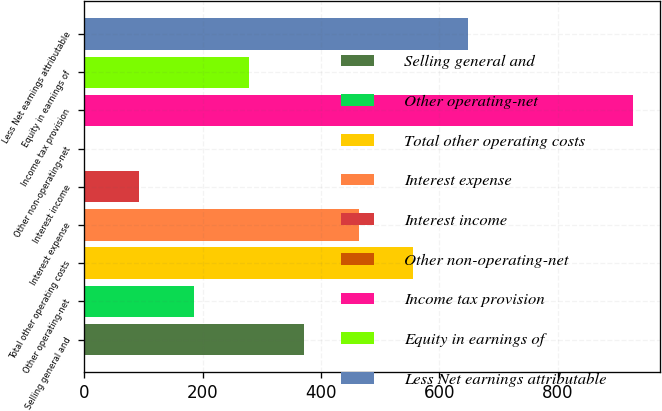Convert chart. <chart><loc_0><loc_0><loc_500><loc_500><bar_chart><fcel>Selling general and<fcel>Other operating-net<fcel>Total other operating costs<fcel>Interest expense<fcel>Interest income<fcel>Other non-operating-net<fcel>Income tax provision<fcel>Equity in earnings of<fcel>Less Net earnings attributable<nl><fcel>370.96<fcel>185.78<fcel>556.14<fcel>463.55<fcel>93.19<fcel>0.6<fcel>926.5<fcel>278.37<fcel>648.73<nl></chart> 